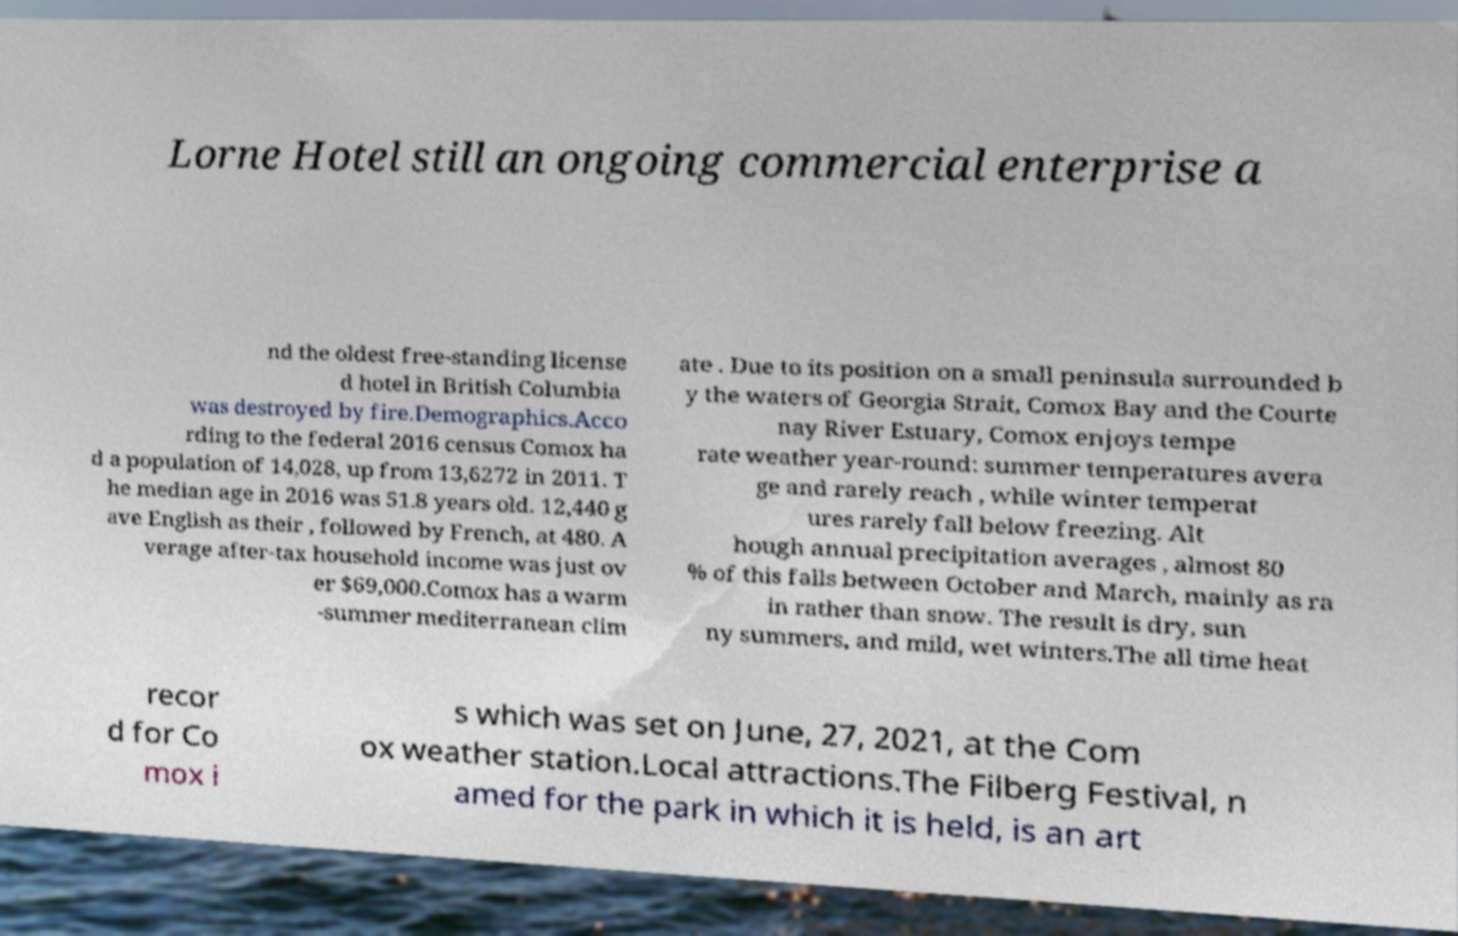Can you read and provide the text displayed in the image?This photo seems to have some interesting text. Can you extract and type it out for me? Lorne Hotel still an ongoing commercial enterprise a nd the oldest free-standing license d hotel in British Columbia was destroyed by fire.Demographics.Acco rding to the federal 2016 census Comox ha d a population of 14,028, up from 13,6272 in 2011. T he median age in 2016 was 51.8 years old. 12,440 g ave English as their , followed by French, at 480. A verage after-tax household income was just ov er $69,000.Comox has a warm -summer mediterranean clim ate . Due to its position on a small peninsula surrounded b y the waters of Georgia Strait, Comox Bay and the Courte nay River Estuary, Comox enjoys tempe rate weather year-round: summer temperatures avera ge and rarely reach , while winter temperat ures rarely fall below freezing. Alt hough annual precipitation averages , almost 80 % of this falls between October and March, mainly as ra in rather than snow. The result is dry, sun ny summers, and mild, wet winters.The all time heat recor d for Co mox i s which was set on June, 27, 2021, at the Com ox weather station.Local attractions.The Filberg Festival, n amed for the park in which it is held, is an art 